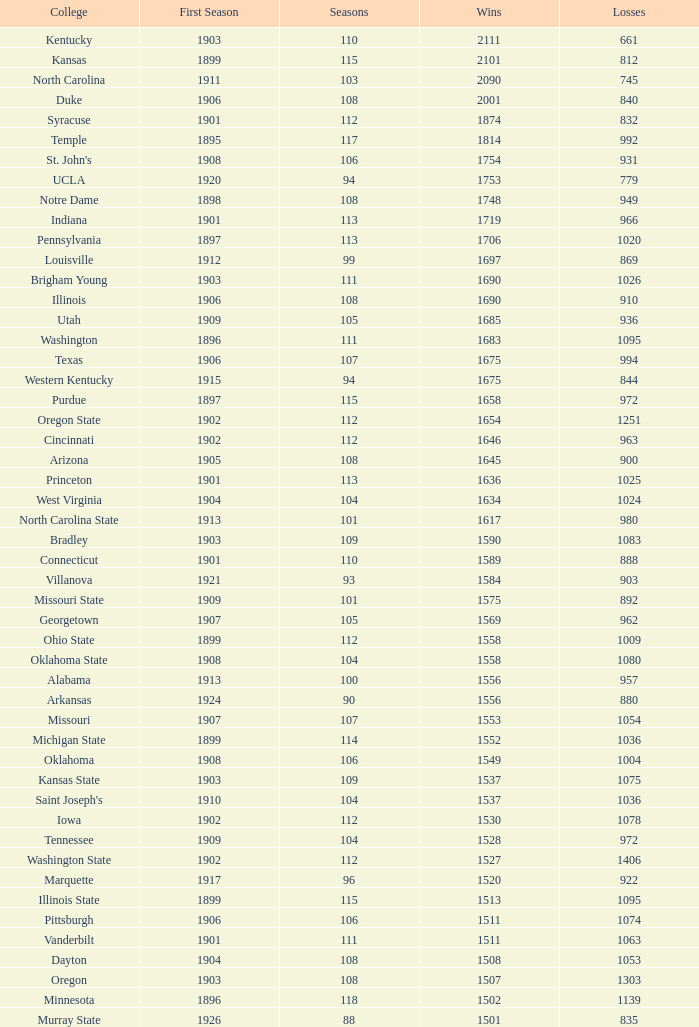What is the count of ranks that have fewer than 992 losses, belong to north carolina state college, and have a season exceeding 101? 0.0. 